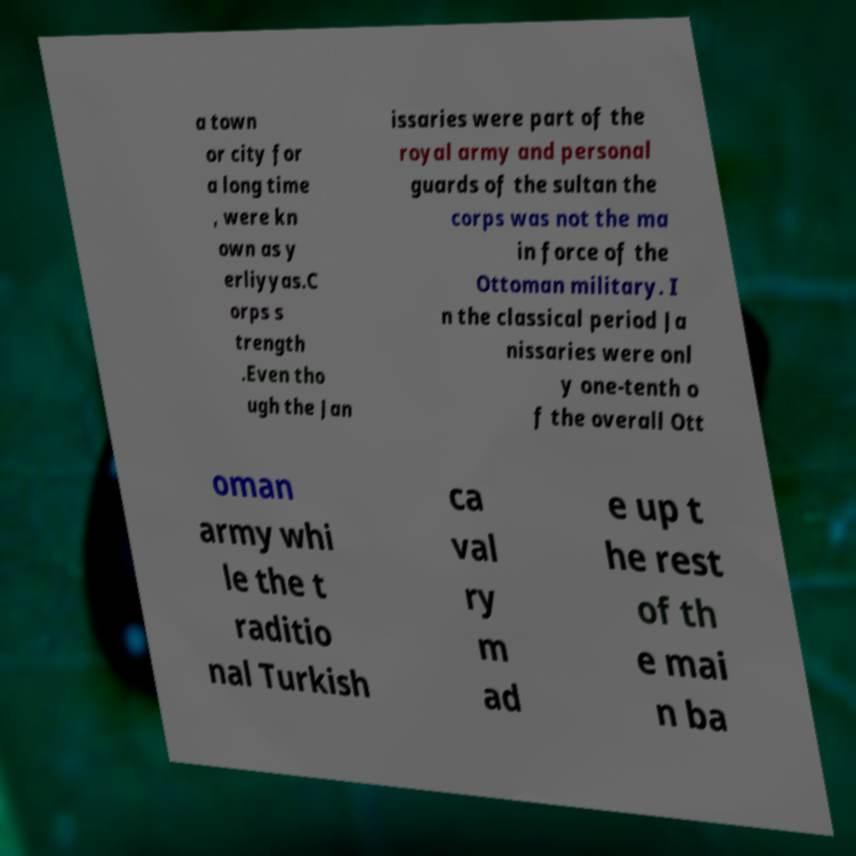Please read and relay the text visible in this image. What does it say? a town or city for a long time , were kn own as y erliyyas.C orps s trength .Even tho ugh the Jan issaries were part of the royal army and personal guards of the sultan the corps was not the ma in force of the Ottoman military. I n the classical period Ja nissaries were onl y one-tenth o f the overall Ott oman army whi le the t raditio nal Turkish ca val ry m ad e up t he rest of th e mai n ba 